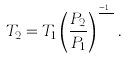<formula> <loc_0><loc_0><loc_500><loc_500>T _ { 2 } = T _ { 1 } \left ( { \frac { P _ { 2 } } { P _ { 1 } } } \right ) ^ { \frac { \gamma - 1 } { \gamma } } .</formula> 